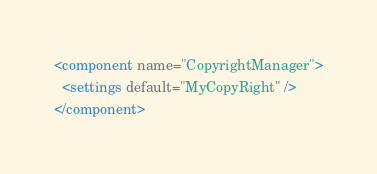<code> <loc_0><loc_0><loc_500><loc_500><_XML_><component name="CopyrightManager">
  <settings default="MyCopyRight" />
</component></code> 